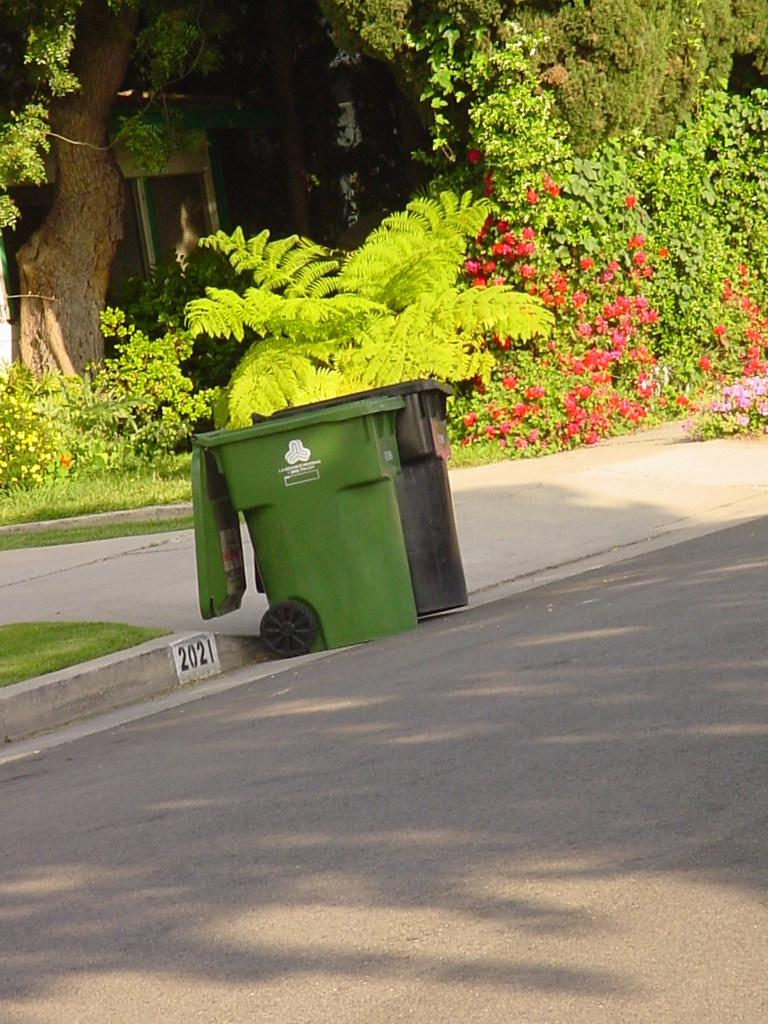What objects are in the foreground of the image? There are two trash cans in the foreground of the image. Where are the trash cans located? The trash cans are placed on the road. What can be seen in the background of the image? There is a group of plants, at least one building, and a tree in the background of the image. What is the belief of the plants in the image? There is no indication in the image that the plants have beliefs, as plants do not have the ability to hold beliefs. 